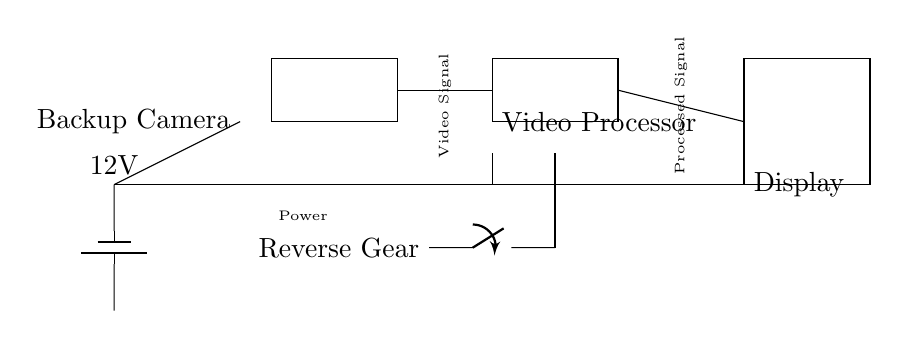What component provides power to the system? The circuit includes a battery, which is designated as the power supply providing 12V to the entire system.
Answer: Battery What is the function of the video processor? The video processor takes the video signal from the backup camera, processes it, and sends the processed video signal to the display.
Answer: Processes video What is the voltage supplied by the battery? The battery supplies a voltage of 12V, as labeled in the circuit.
Answer: 12V What initiates the operation of the backup camera system? The backup camera system is activated by the reverse gear switch, which closes the circuit, allowing power to flow and the camera to operate.
Answer: Reverse gear How many components are connected directly to the power supply? Three components—the backup camera, video processor, and display—are directly connected to the power supply, as they all receive power from the battery connection.
Answer: Three What type of signal is sent from the backup camera to the video processor? The signal sent from the backup camera to the video processor is a video signal, as indicated by the labeled connection in the circuit.
Answer: Video signal What type of switch is used in this circuit? The circuit uses a mechanical switch (indicated as a switch in the diagram) to control the flow of current based on the reverse gear status.
Answer: Mechanical switch 